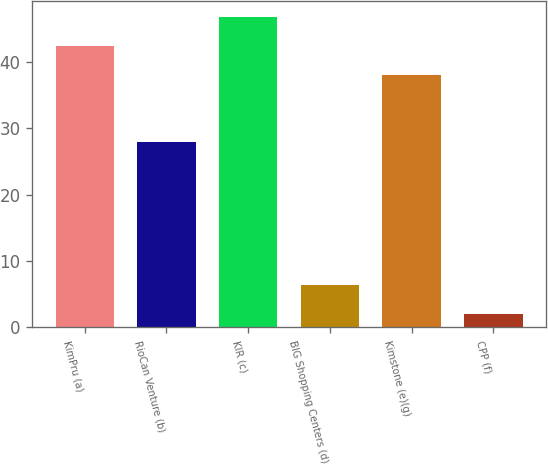<chart> <loc_0><loc_0><loc_500><loc_500><bar_chart><fcel>KimPru (a)<fcel>RioCan Venture (b)<fcel>KIR (c)<fcel>BIG Shopping Centers (d)<fcel>Kimstone (e)(g)<fcel>CPP (f)<nl><fcel>42.4<fcel>28<fcel>46.8<fcel>6.4<fcel>38<fcel>2<nl></chart> 